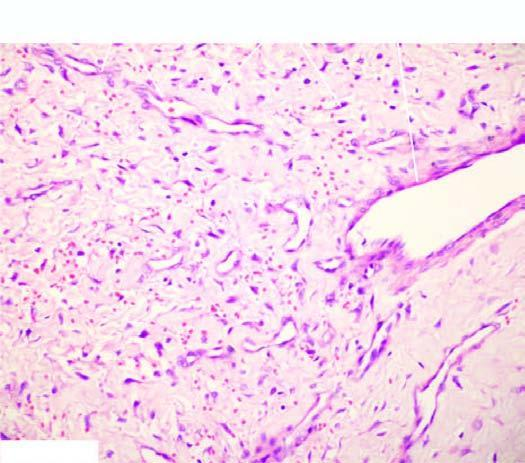did a, normal non-activated platelet, having open canalicular system and the cytoplasmic organelles have incomplete muscle coat?
Answer the question using a single word or phrase. No 